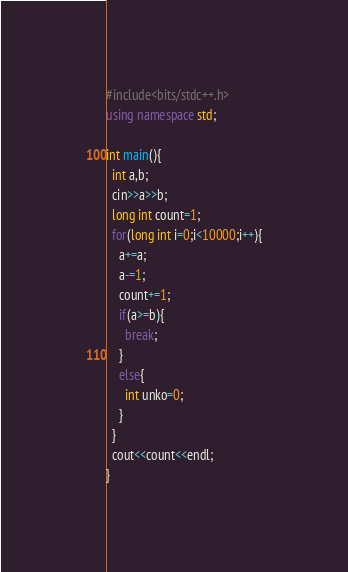Convert code to text. <code><loc_0><loc_0><loc_500><loc_500><_C++_>#include<bits/stdc++.h>
using namespace std;
 
int main(){
  int a,b;
  cin>>a>>b;
  long int count=1;
  for(long int i=0;i<10000;i++){
    a+=a;
    a-=1;
    count+=1;
    if(a>=b){
      break;
    }
    else{
      int unko=0;
    }
  }
  cout<<count<<endl;
}</code> 